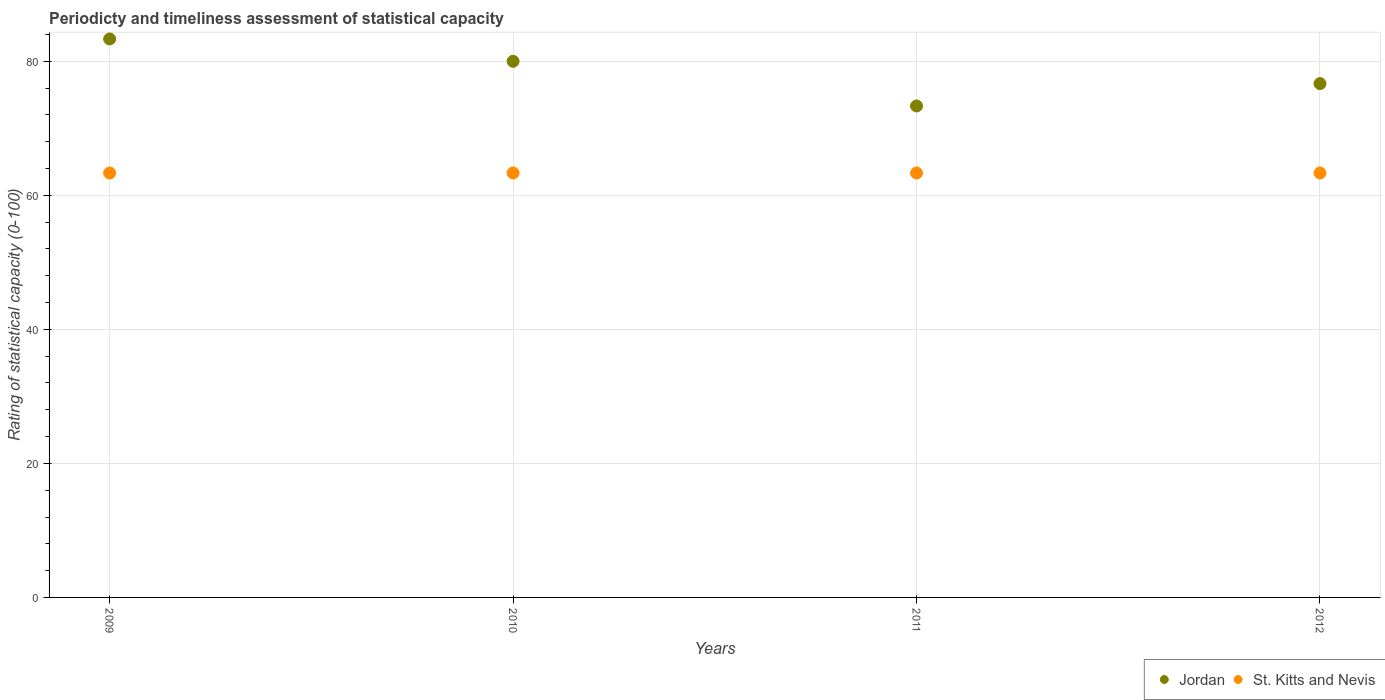What is the rating of statistical capacity in St. Kitts and Nevis in 2012?
Keep it short and to the point. 63.33. Across all years, what is the maximum rating of statistical capacity in St. Kitts and Nevis?
Your response must be concise. 63.33. Across all years, what is the minimum rating of statistical capacity in St. Kitts and Nevis?
Offer a terse response. 63.33. In which year was the rating of statistical capacity in St. Kitts and Nevis minimum?
Keep it short and to the point. 2009. What is the total rating of statistical capacity in St. Kitts and Nevis in the graph?
Your answer should be compact. 253.33. What is the difference between the rating of statistical capacity in Jordan in 2009 and that in 2012?
Offer a very short reply. 6.67. What is the difference between the rating of statistical capacity in St. Kitts and Nevis in 2011 and the rating of statistical capacity in Jordan in 2009?
Make the answer very short. -20. What is the average rating of statistical capacity in Jordan per year?
Make the answer very short. 78.33. In the year 2012, what is the difference between the rating of statistical capacity in Jordan and rating of statistical capacity in St. Kitts and Nevis?
Your answer should be very brief. 13.33. In how many years, is the rating of statistical capacity in Jordan greater than 8?
Your answer should be very brief. 4. What is the ratio of the rating of statistical capacity in St. Kitts and Nevis in 2009 to that in 2012?
Provide a short and direct response. 1. Is the rating of statistical capacity in St. Kitts and Nevis in 2010 less than that in 2011?
Your response must be concise. No. Is the difference between the rating of statistical capacity in Jordan in 2009 and 2010 greater than the difference between the rating of statistical capacity in St. Kitts and Nevis in 2009 and 2010?
Ensure brevity in your answer.  Yes. What is the difference between the highest and the second highest rating of statistical capacity in St. Kitts and Nevis?
Offer a very short reply. 0. Is the rating of statistical capacity in St. Kitts and Nevis strictly greater than the rating of statistical capacity in Jordan over the years?
Provide a short and direct response. No. Is the rating of statistical capacity in St. Kitts and Nevis strictly less than the rating of statistical capacity in Jordan over the years?
Provide a succinct answer. Yes. How many dotlines are there?
Your answer should be compact. 2. How many years are there in the graph?
Keep it short and to the point. 4. What is the difference between two consecutive major ticks on the Y-axis?
Your answer should be compact. 20. How many legend labels are there?
Offer a terse response. 2. How are the legend labels stacked?
Ensure brevity in your answer.  Horizontal. What is the title of the graph?
Make the answer very short. Periodicty and timeliness assessment of statistical capacity. What is the label or title of the Y-axis?
Give a very brief answer. Rating of statistical capacity (0-100). What is the Rating of statistical capacity (0-100) in Jordan in 2009?
Ensure brevity in your answer.  83.33. What is the Rating of statistical capacity (0-100) in St. Kitts and Nevis in 2009?
Give a very brief answer. 63.33. What is the Rating of statistical capacity (0-100) of Jordan in 2010?
Give a very brief answer. 80. What is the Rating of statistical capacity (0-100) of St. Kitts and Nevis in 2010?
Provide a succinct answer. 63.33. What is the Rating of statistical capacity (0-100) of Jordan in 2011?
Provide a short and direct response. 73.33. What is the Rating of statistical capacity (0-100) in St. Kitts and Nevis in 2011?
Offer a very short reply. 63.33. What is the Rating of statistical capacity (0-100) of Jordan in 2012?
Make the answer very short. 76.67. What is the Rating of statistical capacity (0-100) of St. Kitts and Nevis in 2012?
Offer a very short reply. 63.33. Across all years, what is the maximum Rating of statistical capacity (0-100) in Jordan?
Provide a short and direct response. 83.33. Across all years, what is the maximum Rating of statistical capacity (0-100) in St. Kitts and Nevis?
Keep it short and to the point. 63.33. Across all years, what is the minimum Rating of statistical capacity (0-100) in Jordan?
Keep it short and to the point. 73.33. Across all years, what is the minimum Rating of statistical capacity (0-100) in St. Kitts and Nevis?
Ensure brevity in your answer.  63.33. What is the total Rating of statistical capacity (0-100) of Jordan in the graph?
Make the answer very short. 313.33. What is the total Rating of statistical capacity (0-100) of St. Kitts and Nevis in the graph?
Provide a short and direct response. 253.33. What is the difference between the Rating of statistical capacity (0-100) of St. Kitts and Nevis in 2009 and that in 2010?
Make the answer very short. 0. What is the difference between the Rating of statistical capacity (0-100) of St. Kitts and Nevis in 2009 and that in 2011?
Your answer should be very brief. 0. What is the difference between the Rating of statistical capacity (0-100) in Jordan in 2009 and that in 2012?
Your response must be concise. 6.67. What is the difference between the Rating of statistical capacity (0-100) of St. Kitts and Nevis in 2009 and that in 2012?
Provide a succinct answer. 0. What is the difference between the Rating of statistical capacity (0-100) in St. Kitts and Nevis in 2010 and that in 2011?
Offer a terse response. 0. What is the difference between the Rating of statistical capacity (0-100) of Jordan in 2009 and the Rating of statistical capacity (0-100) of St. Kitts and Nevis in 2010?
Your answer should be compact. 20. What is the difference between the Rating of statistical capacity (0-100) of Jordan in 2009 and the Rating of statistical capacity (0-100) of St. Kitts and Nevis in 2011?
Give a very brief answer. 20. What is the difference between the Rating of statistical capacity (0-100) in Jordan in 2009 and the Rating of statistical capacity (0-100) in St. Kitts and Nevis in 2012?
Offer a terse response. 20. What is the difference between the Rating of statistical capacity (0-100) in Jordan in 2010 and the Rating of statistical capacity (0-100) in St. Kitts and Nevis in 2011?
Your answer should be compact. 16.67. What is the difference between the Rating of statistical capacity (0-100) of Jordan in 2010 and the Rating of statistical capacity (0-100) of St. Kitts and Nevis in 2012?
Your answer should be very brief. 16.67. What is the difference between the Rating of statistical capacity (0-100) of Jordan in 2011 and the Rating of statistical capacity (0-100) of St. Kitts and Nevis in 2012?
Keep it short and to the point. 10. What is the average Rating of statistical capacity (0-100) of Jordan per year?
Provide a succinct answer. 78.33. What is the average Rating of statistical capacity (0-100) of St. Kitts and Nevis per year?
Offer a very short reply. 63.33. In the year 2010, what is the difference between the Rating of statistical capacity (0-100) in Jordan and Rating of statistical capacity (0-100) in St. Kitts and Nevis?
Provide a succinct answer. 16.67. In the year 2011, what is the difference between the Rating of statistical capacity (0-100) in Jordan and Rating of statistical capacity (0-100) in St. Kitts and Nevis?
Give a very brief answer. 10. In the year 2012, what is the difference between the Rating of statistical capacity (0-100) of Jordan and Rating of statistical capacity (0-100) of St. Kitts and Nevis?
Offer a very short reply. 13.33. What is the ratio of the Rating of statistical capacity (0-100) in Jordan in 2009 to that in 2010?
Your response must be concise. 1.04. What is the ratio of the Rating of statistical capacity (0-100) in Jordan in 2009 to that in 2011?
Keep it short and to the point. 1.14. What is the ratio of the Rating of statistical capacity (0-100) in St. Kitts and Nevis in 2009 to that in 2011?
Keep it short and to the point. 1. What is the ratio of the Rating of statistical capacity (0-100) in Jordan in 2009 to that in 2012?
Provide a succinct answer. 1.09. What is the ratio of the Rating of statistical capacity (0-100) in Jordan in 2010 to that in 2011?
Ensure brevity in your answer.  1.09. What is the ratio of the Rating of statistical capacity (0-100) in Jordan in 2010 to that in 2012?
Offer a very short reply. 1.04. What is the ratio of the Rating of statistical capacity (0-100) in Jordan in 2011 to that in 2012?
Provide a short and direct response. 0.96. What is the ratio of the Rating of statistical capacity (0-100) of St. Kitts and Nevis in 2011 to that in 2012?
Keep it short and to the point. 1. What is the difference between the highest and the second highest Rating of statistical capacity (0-100) of Jordan?
Provide a short and direct response. 3.33. 